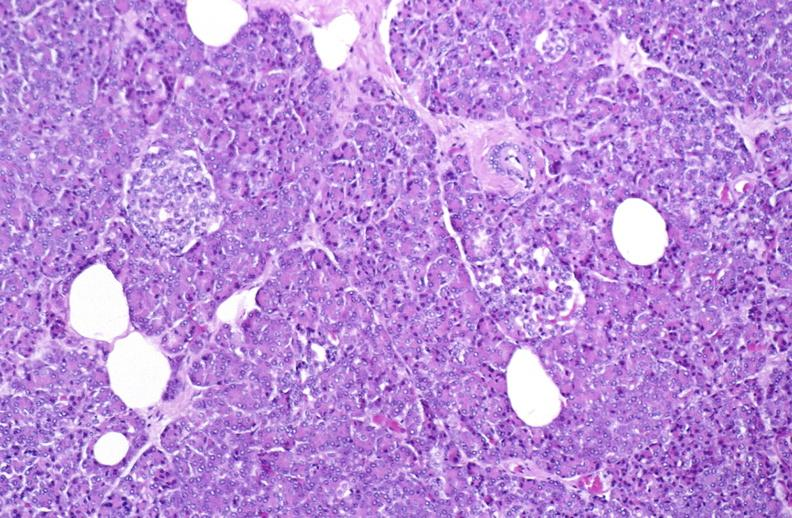does this image show normal pancreas?
Answer the question using a single word or phrase. Yes 